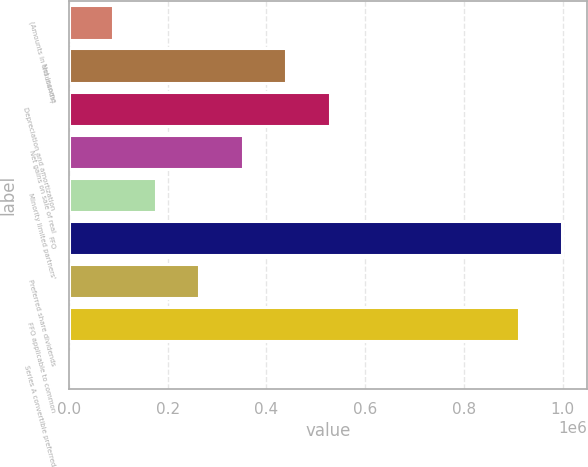Convert chart to OTSL. <chart><loc_0><loc_0><loc_500><loc_500><bar_chart><fcel>(Amounts in thousands)<fcel>Net income<fcel>Depreciation and amortization<fcel>Net gains on sale of real<fcel>Minority limited partners'<fcel>FFO<fcel>Preferred share dividends<fcel>FFO applicable to common<fcel>Series A convertible preferred<nl><fcel>88215.2<fcel>440320<fcel>528346<fcel>352294<fcel>176241<fcel>999412<fcel>264268<fcel>911386<fcel>189<nl></chart> 